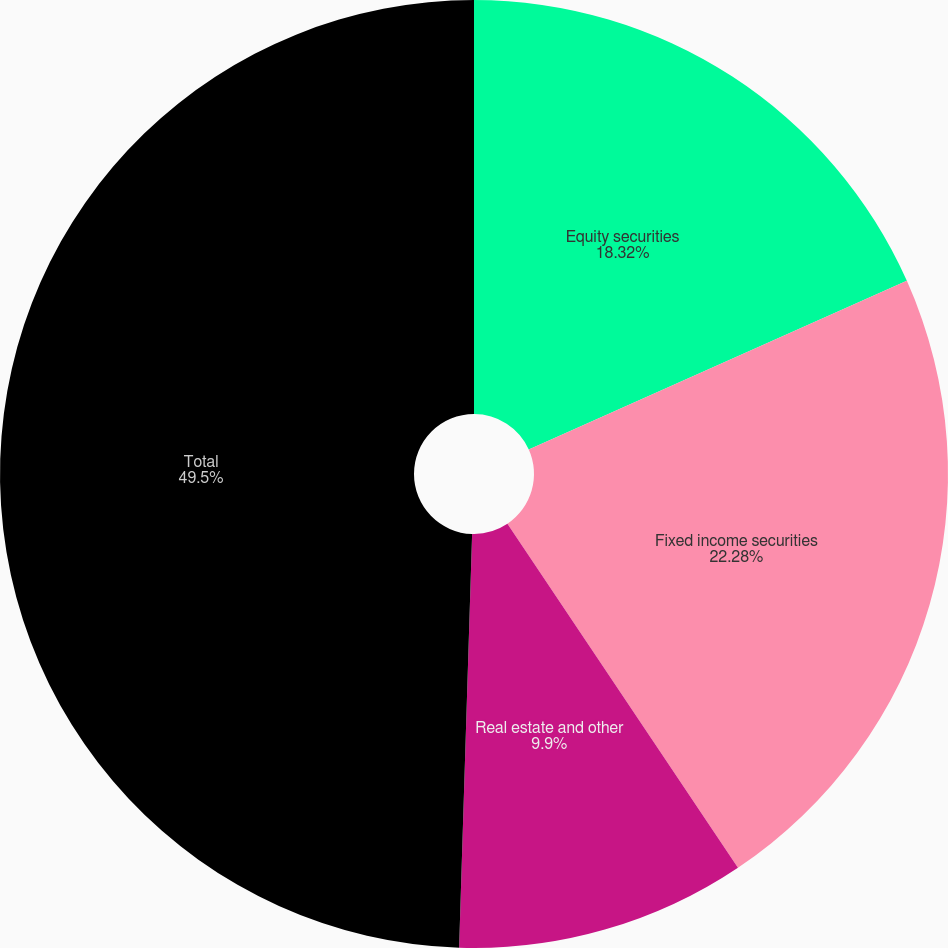Convert chart to OTSL. <chart><loc_0><loc_0><loc_500><loc_500><pie_chart><fcel>Equity securities<fcel>Fixed income securities<fcel>Real estate and other<fcel>Total<nl><fcel>18.32%<fcel>22.28%<fcel>9.9%<fcel>49.5%<nl></chart> 